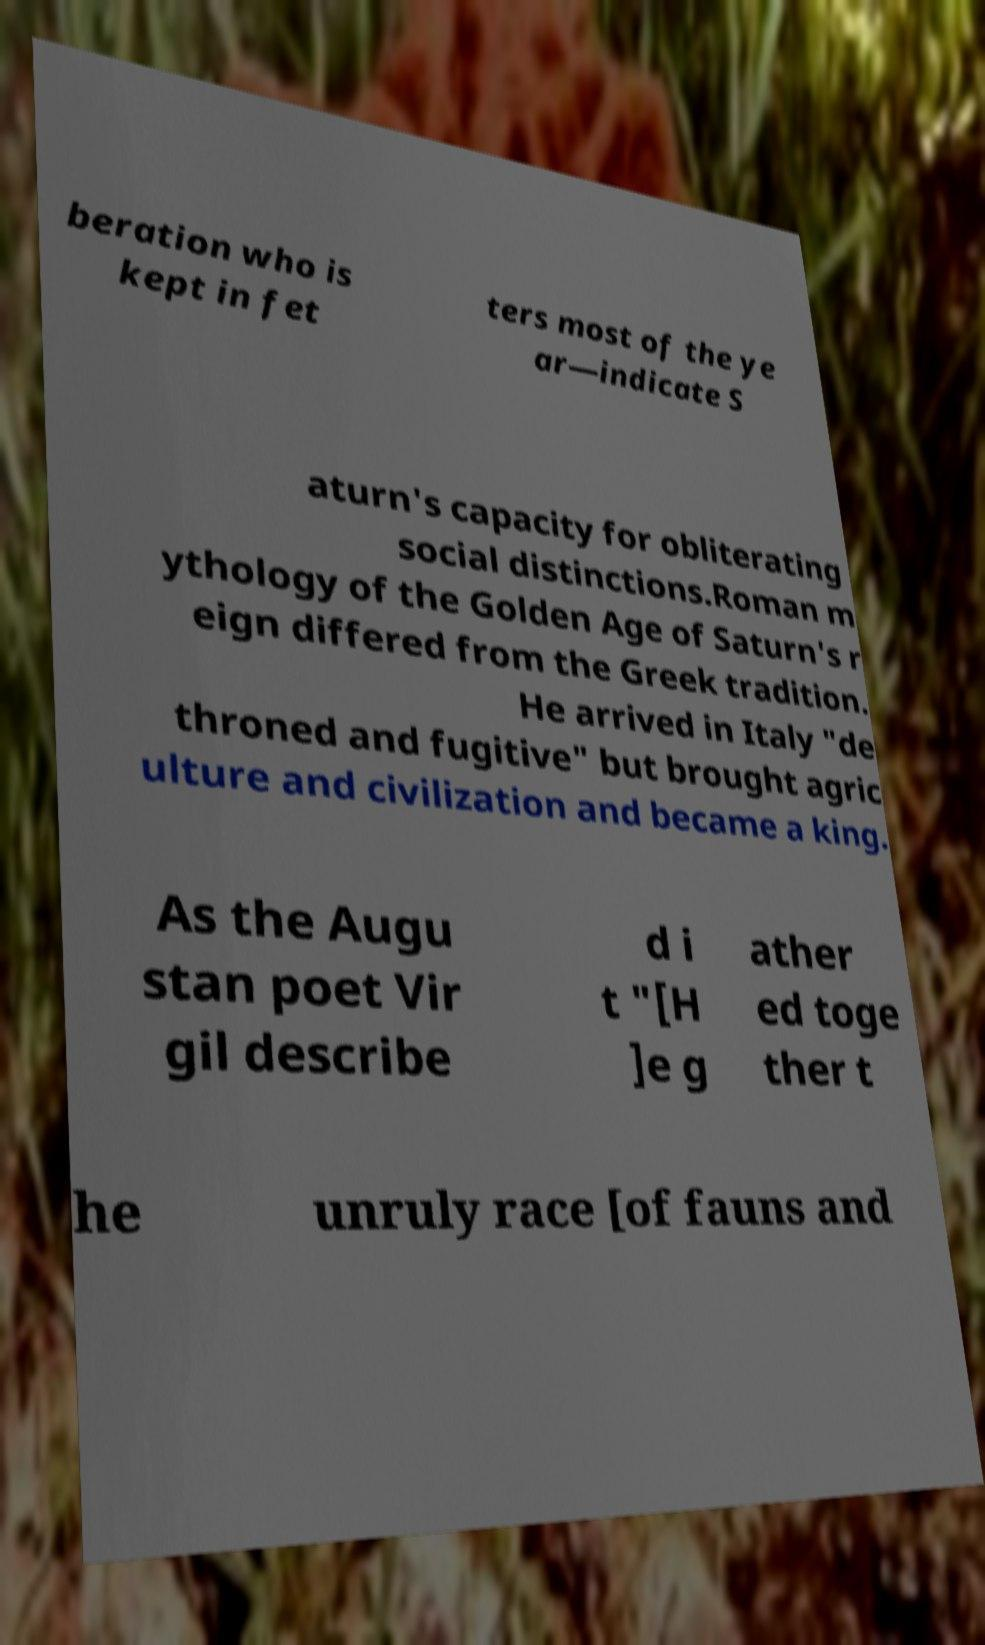Please identify and transcribe the text found in this image. beration who is kept in fet ters most of the ye ar—indicate S aturn's capacity for obliterating social distinctions.Roman m ythology of the Golden Age of Saturn's r eign differed from the Greek tradition. He arrived in Italy "de throned and fugitive" but brought agric ulture and civilization and became a king. As the Augu stan poet Vir gil describe d i t "[H ]e g ather ed toge ther t he unruly race [of fauns and 